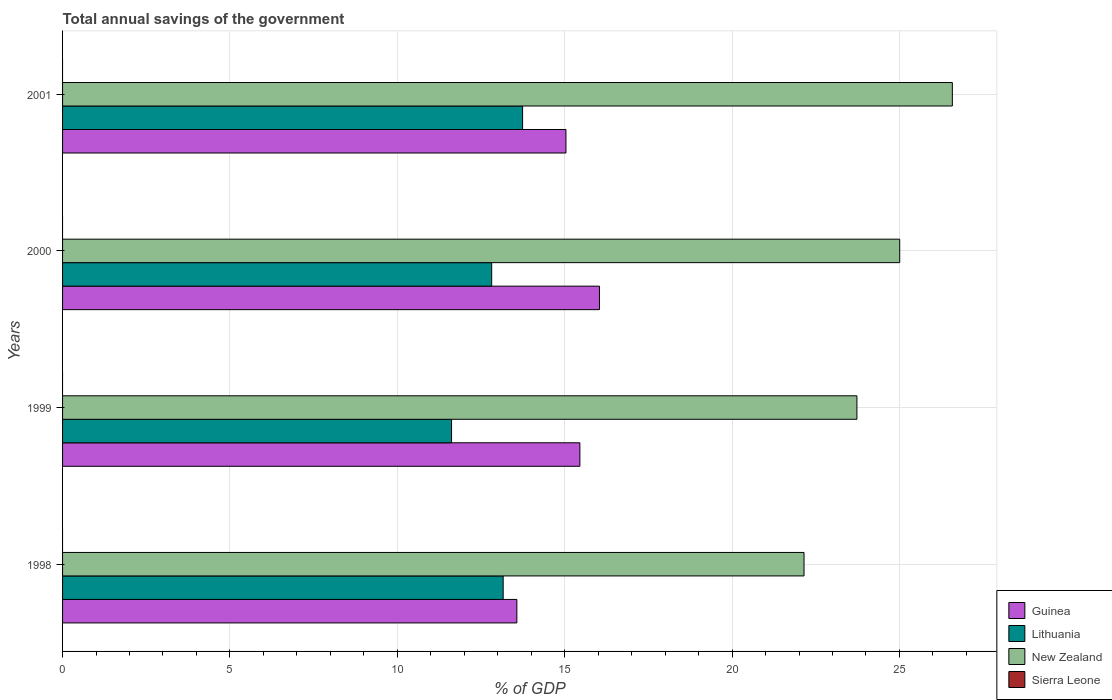How many groups of bars are there?
Give a very brief answer. 4. What is the label of the 3rd group of bars from the top?
Your response must be concise. 1999. In how many cases, is the number of bars for a given year not equal to the number of legend labels?
Ensure brevity in your answer.  4. What is the total annual savings of the government in Lithuania in 2000?
Give a very brief answer. 12.82. Across all years, what is the maximum total annual savings of the government in New Zealand?
Your answer should be compact. 26.58. Across all years, what is the minimum total annual savings of the government in Guinea?
Make the answer very short. 13.57. In which year was the total annual savings of the government in Lithuania maximum?
Provide a short and direct response. 2001. What is the total total annual savings of the government in Sierra Leone in the graph?
Offer a very short reply. 0. What is the difference between the total annual savings of the government in New Zealand in 1999 and that in 2000?
Make the answer very short. -1.28. What is the difference between the total annual savings of the government in Sierra Leone in 2000 and the total annual savings of the government in Lithuania in 1998?
Offer a terse response. -13.16. What is the average total annual savings of the government in New Zealand per year?
Give a very brief answer. 24.37. In the year 2001, what is the difference between the total annual savings of the government in New Zealand and total annual savings of the government in Guinea?
Provide a short and direct response. 11.54. What is the ratio of the total annual savings of the government in Guinea in 1998 to that in 2000?
Ensure brevity in your answer.  0.85. Is the total annual savings of the government in Guinea in 1999 less than that in 2000?
Offer a terse response. Yes. What is the difference between the highest and the second highest total annual savings of the government in New Zealand?
Ensure brevity in your answer.  1.57. What is the difference between the highest and the lowest total annual savings of the government in New Zealand?
Offer a terse response. 4.43. Is the sum of the total annual savings of the government in Guinea in 1999 and 2000 greater than the maximum total annual savings of the government in Lithuania across all years?
Keep it short and to the point. Yes. Is it the case that in every year, the sum of the total annual savings of the government in Lithuania and total annual savings of the government in New Zealand is greater than the sum of total annual savings of the government in Sierra Leone and total annual savings of the government in Guinea?
Your response must be concise. Yes. How many years are there in the graph?
Give a very brief answer. 4. Does the graph contain any zero values?
Provide a short and direct response. Yes. Does the graph contain grids?
Make the answer very short. Yes. Where does the legend appear in the graph?
Give a very brief answer. Bottom right. What is the title of the graph?
Your answer should be very brief. Total annual savings of the government. What is the label or title of the X-axis?
Your answer should be very brief. % of GDP. What is the label or title of the Y-axis?
Provide a succinct answer. Years. What is the % of GDP in Guinea in 1998?
Make the answer very short. 13.57. What is the % of GDP in Lithuania in 1998?
Ensure brevity in your answer.  13.16. What is the % of GDP in New Zealand in 1998?
Ensure brevity in your answer.  22.15. What is the % of GDP in Guinea in 1999?
Your answer should be very brief. 15.45. What is the % of GDP of Lithuania in 1999?
Your answer should be compact. 11.62. What is the % of GDP in New Zealand in 1999?
Provide a succinct answer. 23.73. What is the % of GDP of Sierra Leone in 1999?
Keep it short and to the point. 0. What is the % of GDP of Guinea in 2000?
Provide a short and direct response. 16.04. What is the % of GDP of Lithuania in 2000?
Offer a very short reply. 12.82. What is the % of GDP in New Zealand in 2000?
Give a very brief answer. 25.01. What is the % of GDP of Guinea in 2001?
Offer a terse response. 15.04. What is the % of GDP in Lithuania in 2001?
Give a very brief answer. 13.74. What is the % of GDP in New Zealand in 2001?
Keep it short and to the point. 26.58. What is the % of GDP of Sierra Leone in 2001?
Your answer should be very brief. 0. Across all years, what is the maximum % of GDP in Guinea?
Give a very brief answer. 16.04. Across all years, what is the maximum % of GDP in Lithuania?
Your response must be concise. 13.74. Across all years, what is the maximum % of GDP of New Zealand?
Provide a succinct answer. 26.58. Across all years, what is the minimum % of GDP of Guinea?
Provide a short and direct response. 13.57. Across all years, what is the minimum % of GDP in Lithuania?
Keep it short and to the point. 11.62. Across all years, what is the minimum % of GDP of New Zealand?
Give a very brief answer. 22.15. What is the total % of GDP in Guinea in the graph?
Offer a terse response. 60.1. What is the total % of GDP of Lithuania in the graph?
Make the answer very short. 51.34. What is the total % of GDP in New Zealand in the graph?
Offer a very short reply. 97.47. What is the total % of GDP of Sierra Leone in the graph?
Offer a terse response. 0. What is the difference between the % of GDP of Guinea in 1998 and that in 1999?
Provide a short and direct response. -1.88. What is the difference between the % of GDP of Lithuania in 1998 and that in 1999?
Make the answer very short. 1.54. What is the difference between the % of GDP of New Zealand in 1998 and that in 1999?
Your answer should be compact. -1.58. What is the difference between the % of GDP in Guinea in 1998 and that in 2000?
Your answer should be very brief. -2.47. What is the difference between the % of GDP of Lithuania in 1998 and that in 2000?
Offer a very short reply. 0.34. What is the difference between the % of GDP in New Zealand in 1998 and that in 2000?
Ensure brevity in your answer.  -2.86. What is the difference between the % of GDP of Guinea in 1998 and that in 2001?
Provide a short and direct response. -1.47. What is the difference between the % of GDP in Lithuania in 1998 and that in 2001?
Provide a short and direct response. -0.58. What is the difference between the % of GDP in New Zealand in 1998 and that in 2001?
Ensure brevity in your answer.  -4.43. What is the difference between the % of GDP in Guinea in 1999 and that in 2000?
Your response must be concise. -0.59. What is the difference between the % of GDP in Lithuania in 1999 and that in 2000?
Offer a very short reply. -1.2. What is the difference between the % of GDP of New Zealand in 1999 and that in 2000?
Your response must be concise. -1.28. What is the difference between the % of GDP in Guinea in 1999 and that in 2001?
Ensure brevity in your answer.  0.42. What is the difference between the % of GDP in Lithuania in 1999 and that in 2001?
Your response must be concise. -2.12. What is the difference between the % of GDP in New Zealand in 1999 and that in 2001?
Keep it short and to the point. -2.85. What is the difference between the % of GDP of Lithuania in 2000 and that in 2001?
Offer a very short reply. -0.92. What is the difference between the % of GDP of New Zealand in 2000 and that in 2001?
Offer a terse response. -1.57. What is the difference between the % of GDP of Guinea in 1998 and the % of GDP of Lithuania in 1999?
Your answer should be very brief. 1.95. What is the difference between the % of GDP of Guinea in 1998 and the % of GDP of New Zealand in 1999?
Give a very brief answer. -10.16. What is the difference between the % of GDP of Lithuania in 1998 and the % of GDP of New Zealand in 1999?
Your response must be concise. -10.57. What is the difference between the % of GDP of Guinea in 1998 and the % of GDP of Lithuania in 2000?
Offer a very short reply. 0.75. What is the difference between the % of GDP of Guinea in 1998 and the % of GDP of New Zealand in 2000?
Offer a terse response. -11.44. What is the difference between the % of GDP in Lithuania in 1998 and the % of GDP in New Zealand in 2000?
Provide a short and direct response. -11.85. What is the difference between the % of GDP in Guinea in 1998 and the % of GDP in Lithuania in 2001?
Ensure brevity in your answer.  -0.17. What is the difference between the % of GDP of Guinea in 1998 and the % of GDP of New Zealand in 2001?
Make the answer very short. -13.01. What is the difference between the % of GDP of Lithuania in 1998 and the % of GDP of New Zealand in 2001?
Your answer should be compact. -13.42. What is the difference between the % of GDP in Guinea in 1999 and the % of GDP in Lithuania in 2000?
Your answer should be compact. 2.63. What is the difference between the % of GDP in Guinea in 1999 and the % of GDP in New Zealand in 2000?
Your answer should be compact. -9.55. What is the difference between the % of GDP of Lithuania in 1999 and the % of GDP of New Zealand in 2000?
Your response must be concise. -13.39. What is the difference between the % of GDP in Guinea in 1999 and the % of GDP in Lithuania in 2001?
Ensure brevity in your answer.  1.71. What is the difference between the % of GDP of Guinea in 1999 and the % of GDP of New Zealand in 2001?
Ensure brevity in your answer.  -11.13. What is the difference between the % of GDP in Lithuania in 1999 and the % of GDP in New Zealand in 2001?
Provide a short and direct response. -14.96. What is the difference between the % of GDP in Guinea in 2000 and the % of GDP in Lithuania in 2001?
Provide a short and direct response. 2.3. What is the difference between the % of GDP in Guinea in 2000 and the % of GDP in New Zealand in 2001?
Make the answer very short. -10.54. What is the difference between the % of GDP of Lithuania in 2000 and the % of GDP of New Zealand in 2001?
Your answer should be very brief. -13.76. What is the average % of GDP in Guinea per year?
Make the answer very short. 15.03. What is the average % of GDP of Lithuania per year?
Provide a short and direct response. 12.84. What is the average % of GDP of New Zealand per year?
Offer a very short reply. 24.37. What is the average % of GDP in Sierra Leone per year?
Ensure brevity in your answer.  0. In the year 1998, what is the difference between the % of GDP in Guinea and % of GDP in Lithuania?
Offer a terse response. 0.41. In the year 1998, what is the difference between the % of GDP in Guinea and % of GDP in New Zealand?
Provide a succinct answer. -8.58. In the year 1998, what is the difference between the % of GDP in Lithuania and % of GDP in New Zealand?
Your answer should be compact. -8.99. In the year 1999, what is the difference between the % of GDP of Guinea and % of GDP of Lithuania?
Your answer should be compact. 3.83. In the year 1999, what is the difference between the % of GDP in Guinea and % of GDP in New Zealand?
Ensure brevity in your answer.  -8.28. In the year 1999, what is the difference between the % of GDP of Lithuania and % of GDP of New Zealand?
Provide a short and direct response. -12.11. In the year 2000, what is the difference between the % of GDP of Guinea and % of GDP of Lithuania?
Your answer should be compact. 3.22. In the year 2000, what is the difference between the % of GDP of Guinea and % of GDP of New Zealand?
Make the answer very short. -8.97. In the year 2000, what is the difference between the % of GDP in Lithuania and % of GDP in New Zealand?
Offer a terse response. -12.19. In the year 2001, what is the difference between the % of GDP of Guinea and % of GDP of Lithuania?
Give a very brief answer. 1.3. In the year 2001, what is the difference between the % of GDP in Guinea and % of GDP in New Zealand?
Provide a succinct answer. -11.54. In the year 2001, what is the difference between the % of GDP in Lithuania and % of GDP in New Zealand?
Keep it short and to the point. -12.84. What is the ratio of the % of GDP in Guinea in 1998 to that in 1999?
Offer a very short reply. 0.88. What is the ratio of the % of GDP in Lithuania in 1998 to that in 1999?
Your answer should be compact. 1.13. What is the ratio of the % of GDP in New Zealand in 1998 to that in 1999?
Your response must be concise. 0.93. What is the ratio of the % of GDP in Guinea in 1998 to that in 2000?
Ensure brevity in your answer.  0.85. What is the ratio of the % of GDP in Lithuania in 1998 to that in 2000?
Provide a short and direct response. 1.03. What is the ratio of the % of GDP in New Zealand in 1998 to that in 2000?
Provide a short and direct response. 0.89. What is the ratio of the % of GDP of Guinea in 1998 to that in 2001?
Ensure brevity in your answer.  0.9. What is the ratio of the % of GDP of Lithuania in 1998 to that in 2001?
Provide a succinct answer. 0.96. What is the ratio of the % of GDP in Guinea in 1999 to that in 2000?
Ensure brevity in your answer.  0.96. What is the ratio of the % of GDP of Lithuania in 1999 to that in 2000?
Provide a succinct answer. 0.91. What is the ratio of the % of GDP of New Zealand in 1999 to that in 2000?
Your answer should be compact. 0.95. What is the ratio of the % of GDP of Guinea in 1999 to that in 2001?
Ensure brevity in your answer.  1.03. What is the ratio of the % of GDP in Lithuania in 1999 to that in 2001?
Your answer should be very brief. 0.85. What is the ratio of the % of GDP of New Zealand in 1999 to that in 2001?
Make the answer very short. 0.89. What is the ratio of the % of GDP of Guinea in 2000 to that in 2001?
Keep it short and to the point. 1.07. What is the ratio of the % of GDP of Lithuania in 2000 to that in 2001?
Keep it short and to the point. 0.93. What is the ratio of the % of GDP of New Zealand in 2000 to that in 2001?
Your answer should be very brief. 0.94. What is the difference between the highest and the second highest % of GDP of Guinea?
Your answer should be compact. 0.59. What is the difference between the highest and the second highest % of GDP of Lithuania?
Ensure brevity in your answer.  0.58. What is the difference between the highest and the second highest % of GDP in New Zealand?
Your answer should be compact. 1.57. What is the difference between the highest and the lowest % of GDP in Guinea?
Provide a short and direct response. 2.47. What is the difference between the highest and the lowest % of GDP of Lithuania?
Offer a terse response. 2.12. What is the difference between the highest and the lowest % of GDP in New Zealand?
Offer a very short reply. 4.43. 